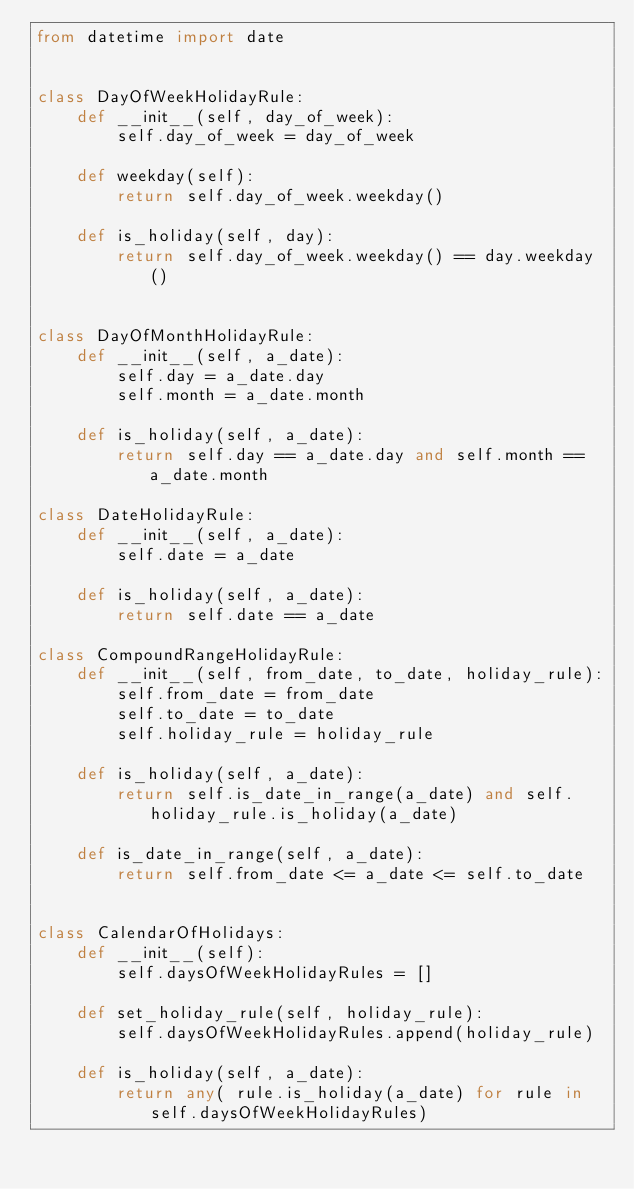Convert code to text. <code><loc_0><loc_0><loc_500><loc_500><_Python_>from datetime import date


class DayOfWeekHolidayRule:
    def __init__(self, day_of_week):
        self.day_of_week = day_of_week

    def weekday(self):
        return self.day_of_week.weekday()

    def is_holiday(self, day):
        return self.day_of_week.weekday() == day.weekday()


class DayOfMonthHolidayRule:
    def __init__(self, a_date):
        self.day = a_date.day
        self.month = a_date.month

    def is_holiday(self, a_date):
        return self.day == a_date.day and self.month == a_date.month

class DateHolidayRule:
    def __init__(self, a_date):
        self.date = a_date

    def is_holiday(self, a_date):
        return self.date == a_date

class CompoundRangeHolidayRule:
    def __init__(self, from_date, to_date, holiday_rule):
        self.from_date = from_date
        self.to_date = to_date
        self.holiday_rule = holiday_rule

    def is_holiday(self, a_date):
        return self.is_date_in_range(a_date) and self.holiday_rule.is_holiday(a_date)

    def is_date_in_range(self, a_date):
        return self.from_date <= a_date <= self.to_date


class CalendarOfHolidays:
    def __init__(self):
        self.daysOfWeekHolidayRules = []

    def set_holiday_rule(self, holiday_rule):
        self.daysOfWeekHolidayRules.append(holiday_rule)

    def is_holiday(self, a_date):
        return any( rule.is_holiday(a_date) for rule in self.daysOfWeekHolidayRules)
</code> 